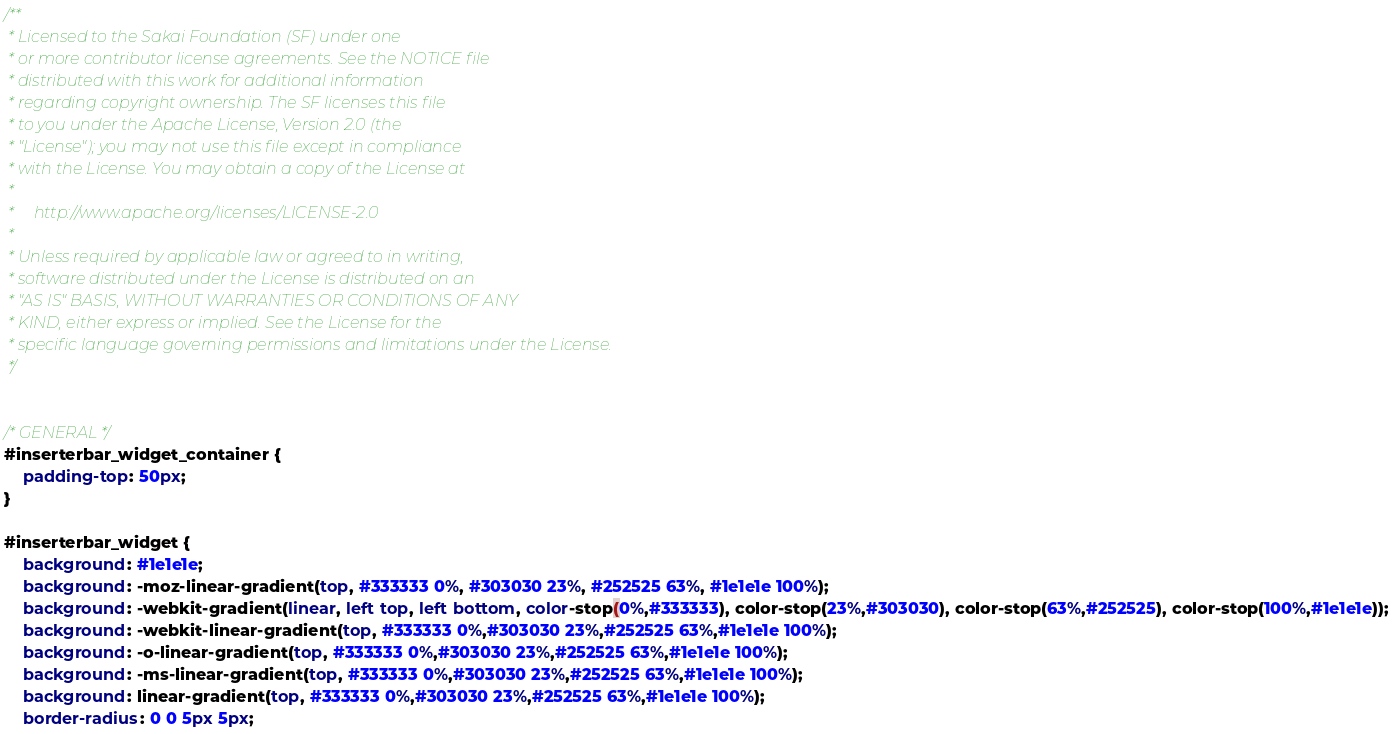Convert code to text. <code><loc_0><loc_0><loc_500><loc_500><_CSS_>/**
 * Licensed to the Sakai Foundation (SF) under one
 * or more contributor license agreements. See the NOTICE file
 * distributed with this work for additional information
 * regarding copyright ownership. The SF licenses this file
 * to you under the Apache License, Version 2.0 (the
 * "License"); you may not use this file except in compliance
 * with the License. You may obtain a copy of the License at
 *
 *     http://www.apache.org/licenses/LICENSE-2.0
 *
 * Unless required by applicable law or agreed to in writing,
 * software distributed under the License is distributed on an
 * "AS IS" BASIS, WITHOUT WARRANTIES OR CONDITIONS OF ANY
 * KIND, either express or implied. See the License for the
 * specific language governing permissions and limitations under the License.
 */


/* GENERAL */
#inserterbar_widget_container {
    padding-top: 50px;
}

#inserterbar_widget {
    background: #1e1e1e;
    background: -moz-linear-gradient(top, #333333 0%, #303030 23%, #252525 63%, #1e1e1e 100%);
    background: -webkit-gradient(linear, left top, left bottom, color-stop(0%,#333333), color-stop(23%,#303030), color-stop(63%,#252525), color-stop(100%,#1e1e1e));
    background: -webkit-linear-gradient(top, #333333 0%,#303030 23%,#252525 63%,#1e1e1e 100%);
    background: -o-linear-gradient(top, #333333 0%,#303030 23%,#252525 63%,#1e1e1e 100%);
    background: -ms-linear-gradient(top, #333333 0%,#303030 23%,#252525 63%,#1e1e1e 100%);
    background: linear-gradient(top, #333333 0%,#303030 23%,#252525 63%,#1e1e1e 100%);
    border-radius: 0 0 5px 5px;</code> 